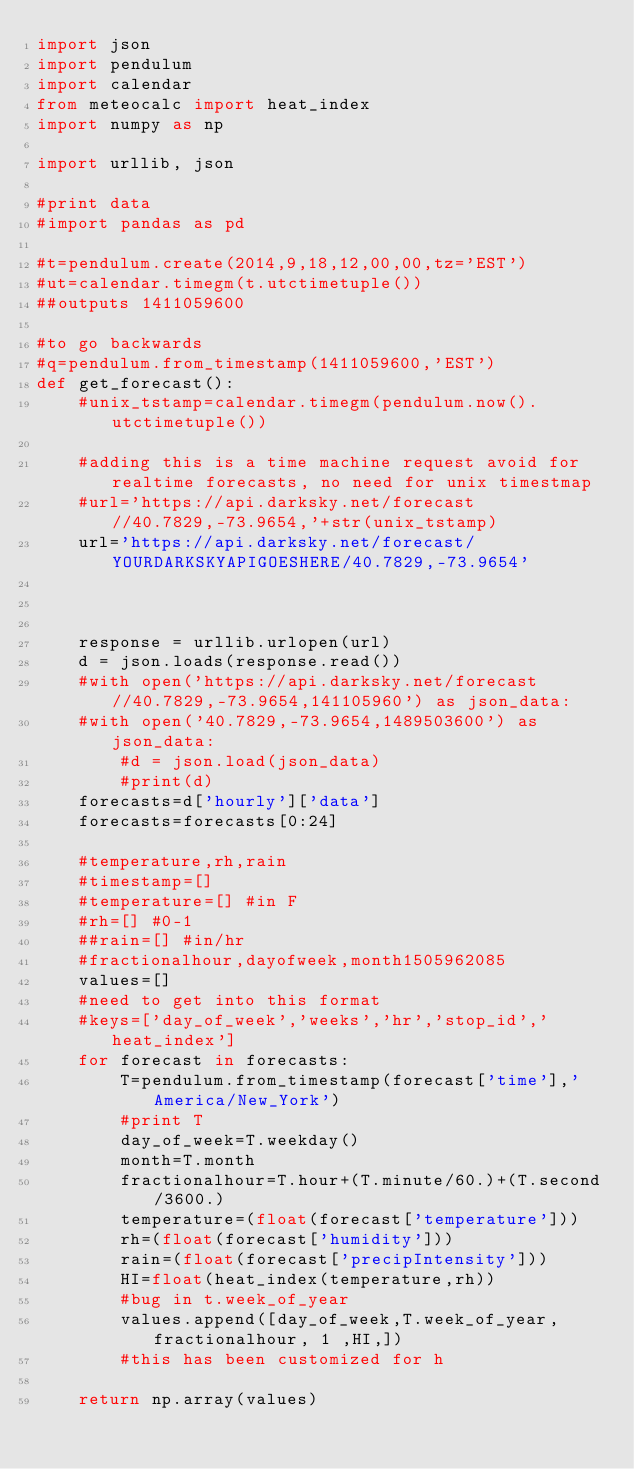Convert code to text. <code><loc_0><loc_0><loc_500><loc_500><_Python_>import json
import pendulum
import calendar
from meteocalc import heat_index
import numpy as np

import urllib, json

#print data
#import pandas as pd

#t=pendulum.create(2014,9,18,12,00,00,tz='EST')
#ut=calendar.timegm(t.utctimetuple())
##outputs 1411059600

#to go backwards
#q=pendulum.from_timestamp(1411059600,'EST')
def get_forecast():
    #unix_tstamp=calendar.timegm(pendulum.now().utctimetuple())

    #adding this is a time machine request avoid for realtime forecasts, no need for unix timestmap
    #url='https://api.darksky.net/forecast//40.7829,-73.9654,'+str(unix_tstamp)
    url='https://api.darksky.net/forecast/YOURDARKSKYAPIGOESHERE/40.7829,-73.9654'



    response = urllib.urlopen(url)
    d = json.loads(response.read())
    #with open('https://api.darksky.net/forecast//40.7829,-73.9654,141105960') as json_data:
    #with open('40.7829,-73.9654,1489503600') as json_data:
        #d = json.load(json_data)
        #print(d)
    forecasts=d['hourly']['data']
    forecasts=forecasts[0:24]

    #temperature,rh,rain
    #timestamp=[]
    #temperature=[] #in F
    #rh=[] #0-1
    ##rain=[] #in/hr
    #fractionalhour,dayofweek,month1505962085
    values=[]
    #need to get into this format
    #keys=['day_of_week','weeks','hr','stop_id','heat_index']
    for forecast in forecasts:
        T=pendulum.from_timestamp(forecast['time'],'America/New_York')
        #print T
        day_of_week=T.weekday()
        month=T.month
        fractionalhour=T.hour+(T.minute/60.)+(T.second/3600.)
        temperature=(float(forecast['temperature']))
        rh=(float(forecast['humidity']))
        rain=(float(forecast['precipIntensity']))
        HI=float(heat_index(temperature,rh))
        #bug in t.week_of_year
        values.append([day_of_week,T.week_of_year, fractionalhour, 1 ,HI,])
        #this has been customized for h

    return np.array(values)
</code> 